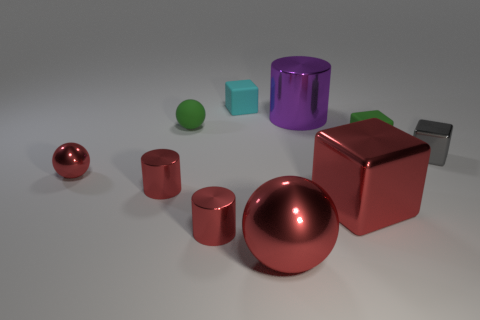What size is the purple metallic thing?
Keep it short and to the point. Large. What shape is the small green matte object that is on the left side of the shiny cube in front of the gray block?
Give a very brief answer. Sphere. There is a cyan rubber thing that is the same shape as the gray object; what size is it?
Provide a short and direct response. Small. There is a tiny metallic cylinder in front of the red block; what color is it?
Keep it short and to the point. Red. There is a object that is behind the cylinder behind the small green sphere behind the big red sphere; what is its material?
Ensure brevity in your answer.  Rubber. There is a metallic block that is on the left side of the small shiny thing that is on the right side of the large purple thing; what size is it?
Your answer should be compact. Large. What is the color of the other small rubber object that is the same shape as the cyan matte object?
Offer a terse response. Green. How many large metal things are the same color as the large shiny cube?
Your response must be concise. 1. Is the purple cylinder the same size as the gray metal block?
Your response must be concise. No. What material is the small gray cube?
Offer a terse response. Metal. 